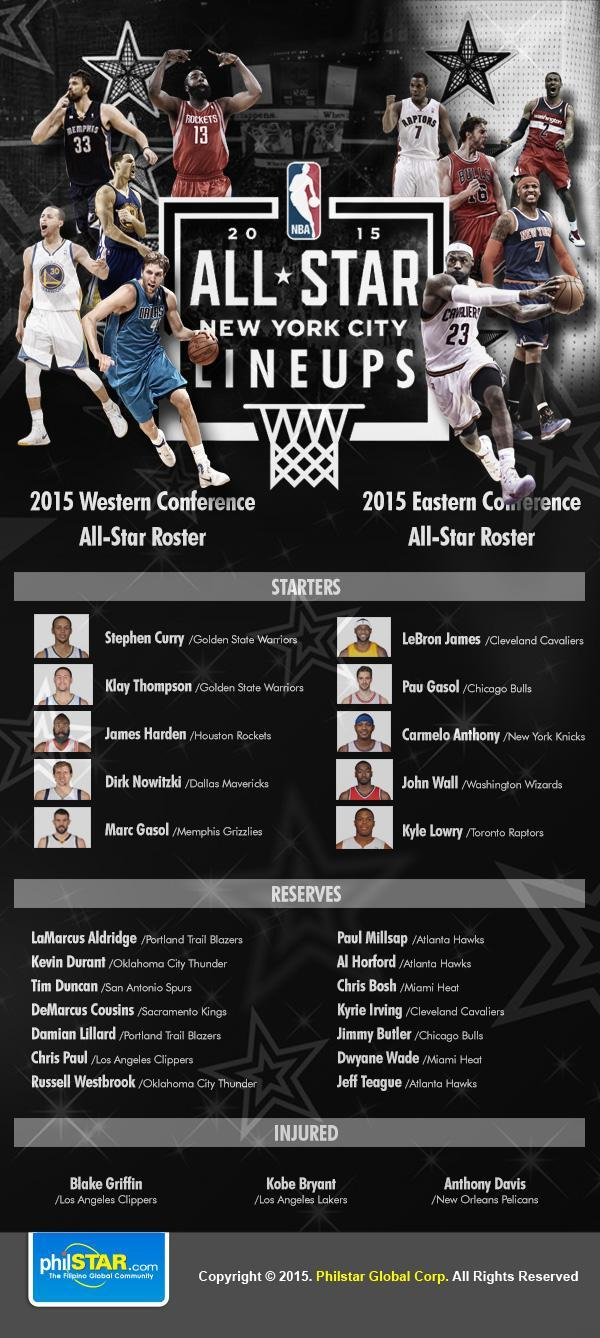What are the names of reserve players from the team Atlanta Hawks?
Answer the question with a short phrase. Paul Millsap, Al Horford, Jeff Teague How many are injured? 3 How many reserves from the team Miami Heat? 2 How many starters from the team Golden State Warriors? 2 How many reserves from the Atlanta Hawks team? 3 